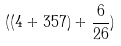<formula> <loc_0><loc_0><loc_500><loc_500>( ( 4 + 3 5 7 ) + \frac { 6 } { 2 6 } )</formula> 